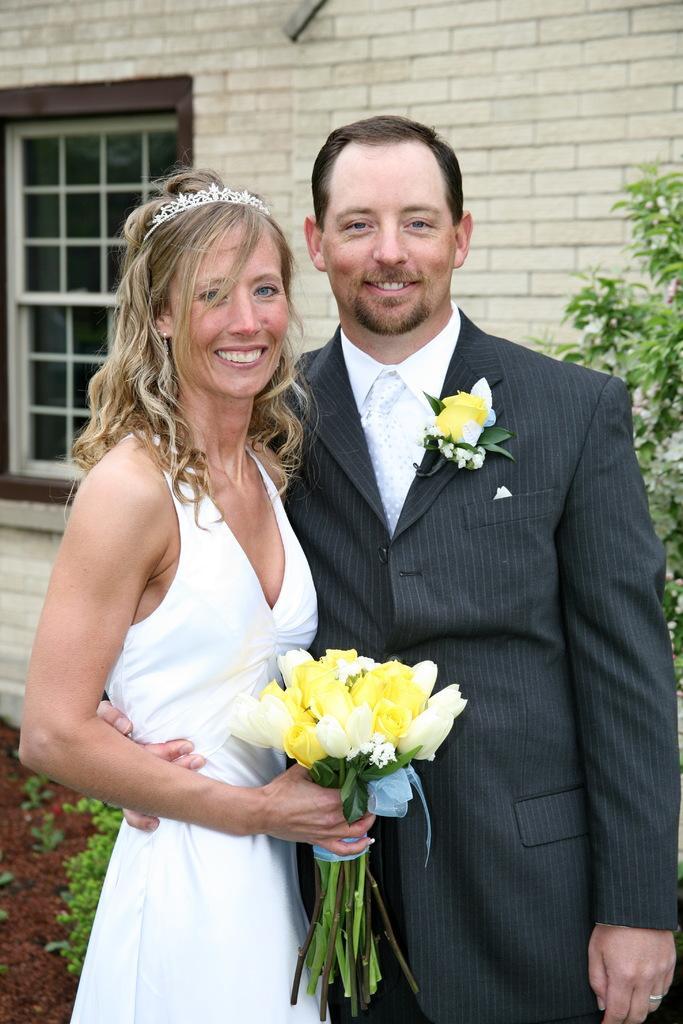Describe this image in one or two sentences. In this picture there is a man with black color suit standing in front, smiling in giving pose. Beside there is a woman wearing white gown with crown on the head and holding yellow color flowers in the hands. Behind there is a brick wall with glass window and some plants. 